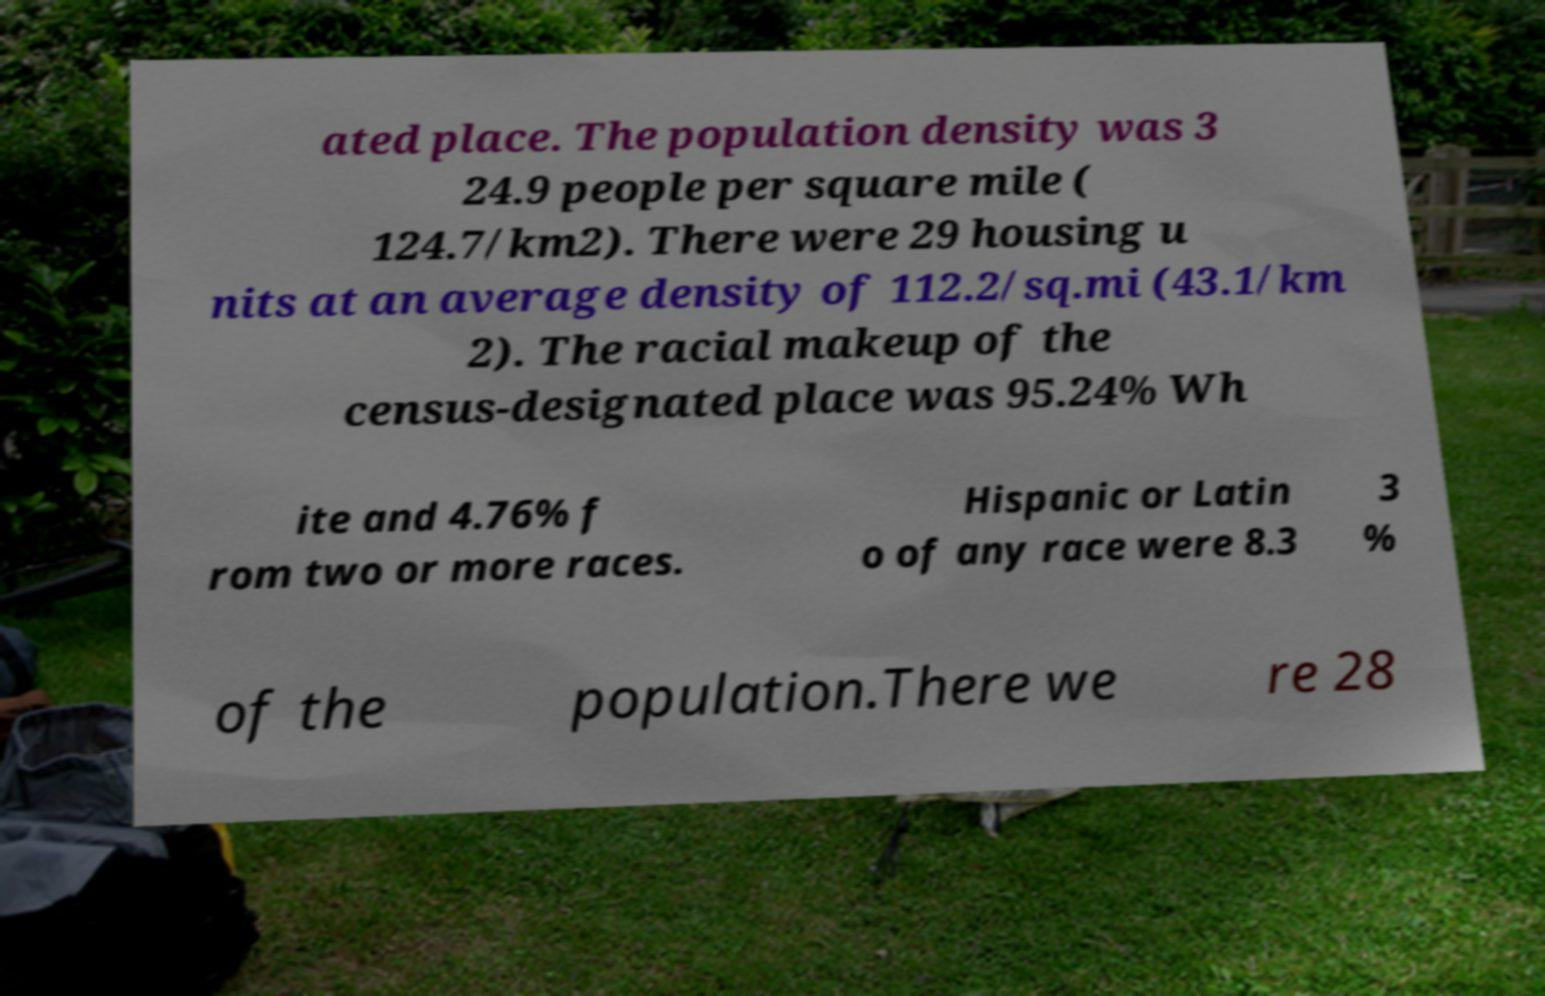For documentation purposes, I need the text within this image transcribed. Could you provide that? ated place. The population density was 3 24.9 people per square mile ( 124.7/km2). There were 29 housing u nits at an average density of 112.2/sq.mi (43.1/km 2). The racial makeup of the census-designated place was 95.24% Wh ite and 4.76% f rom two or more races. Hispanic or Latin o of any race were 8.3 3 % of the population.There we re 28 